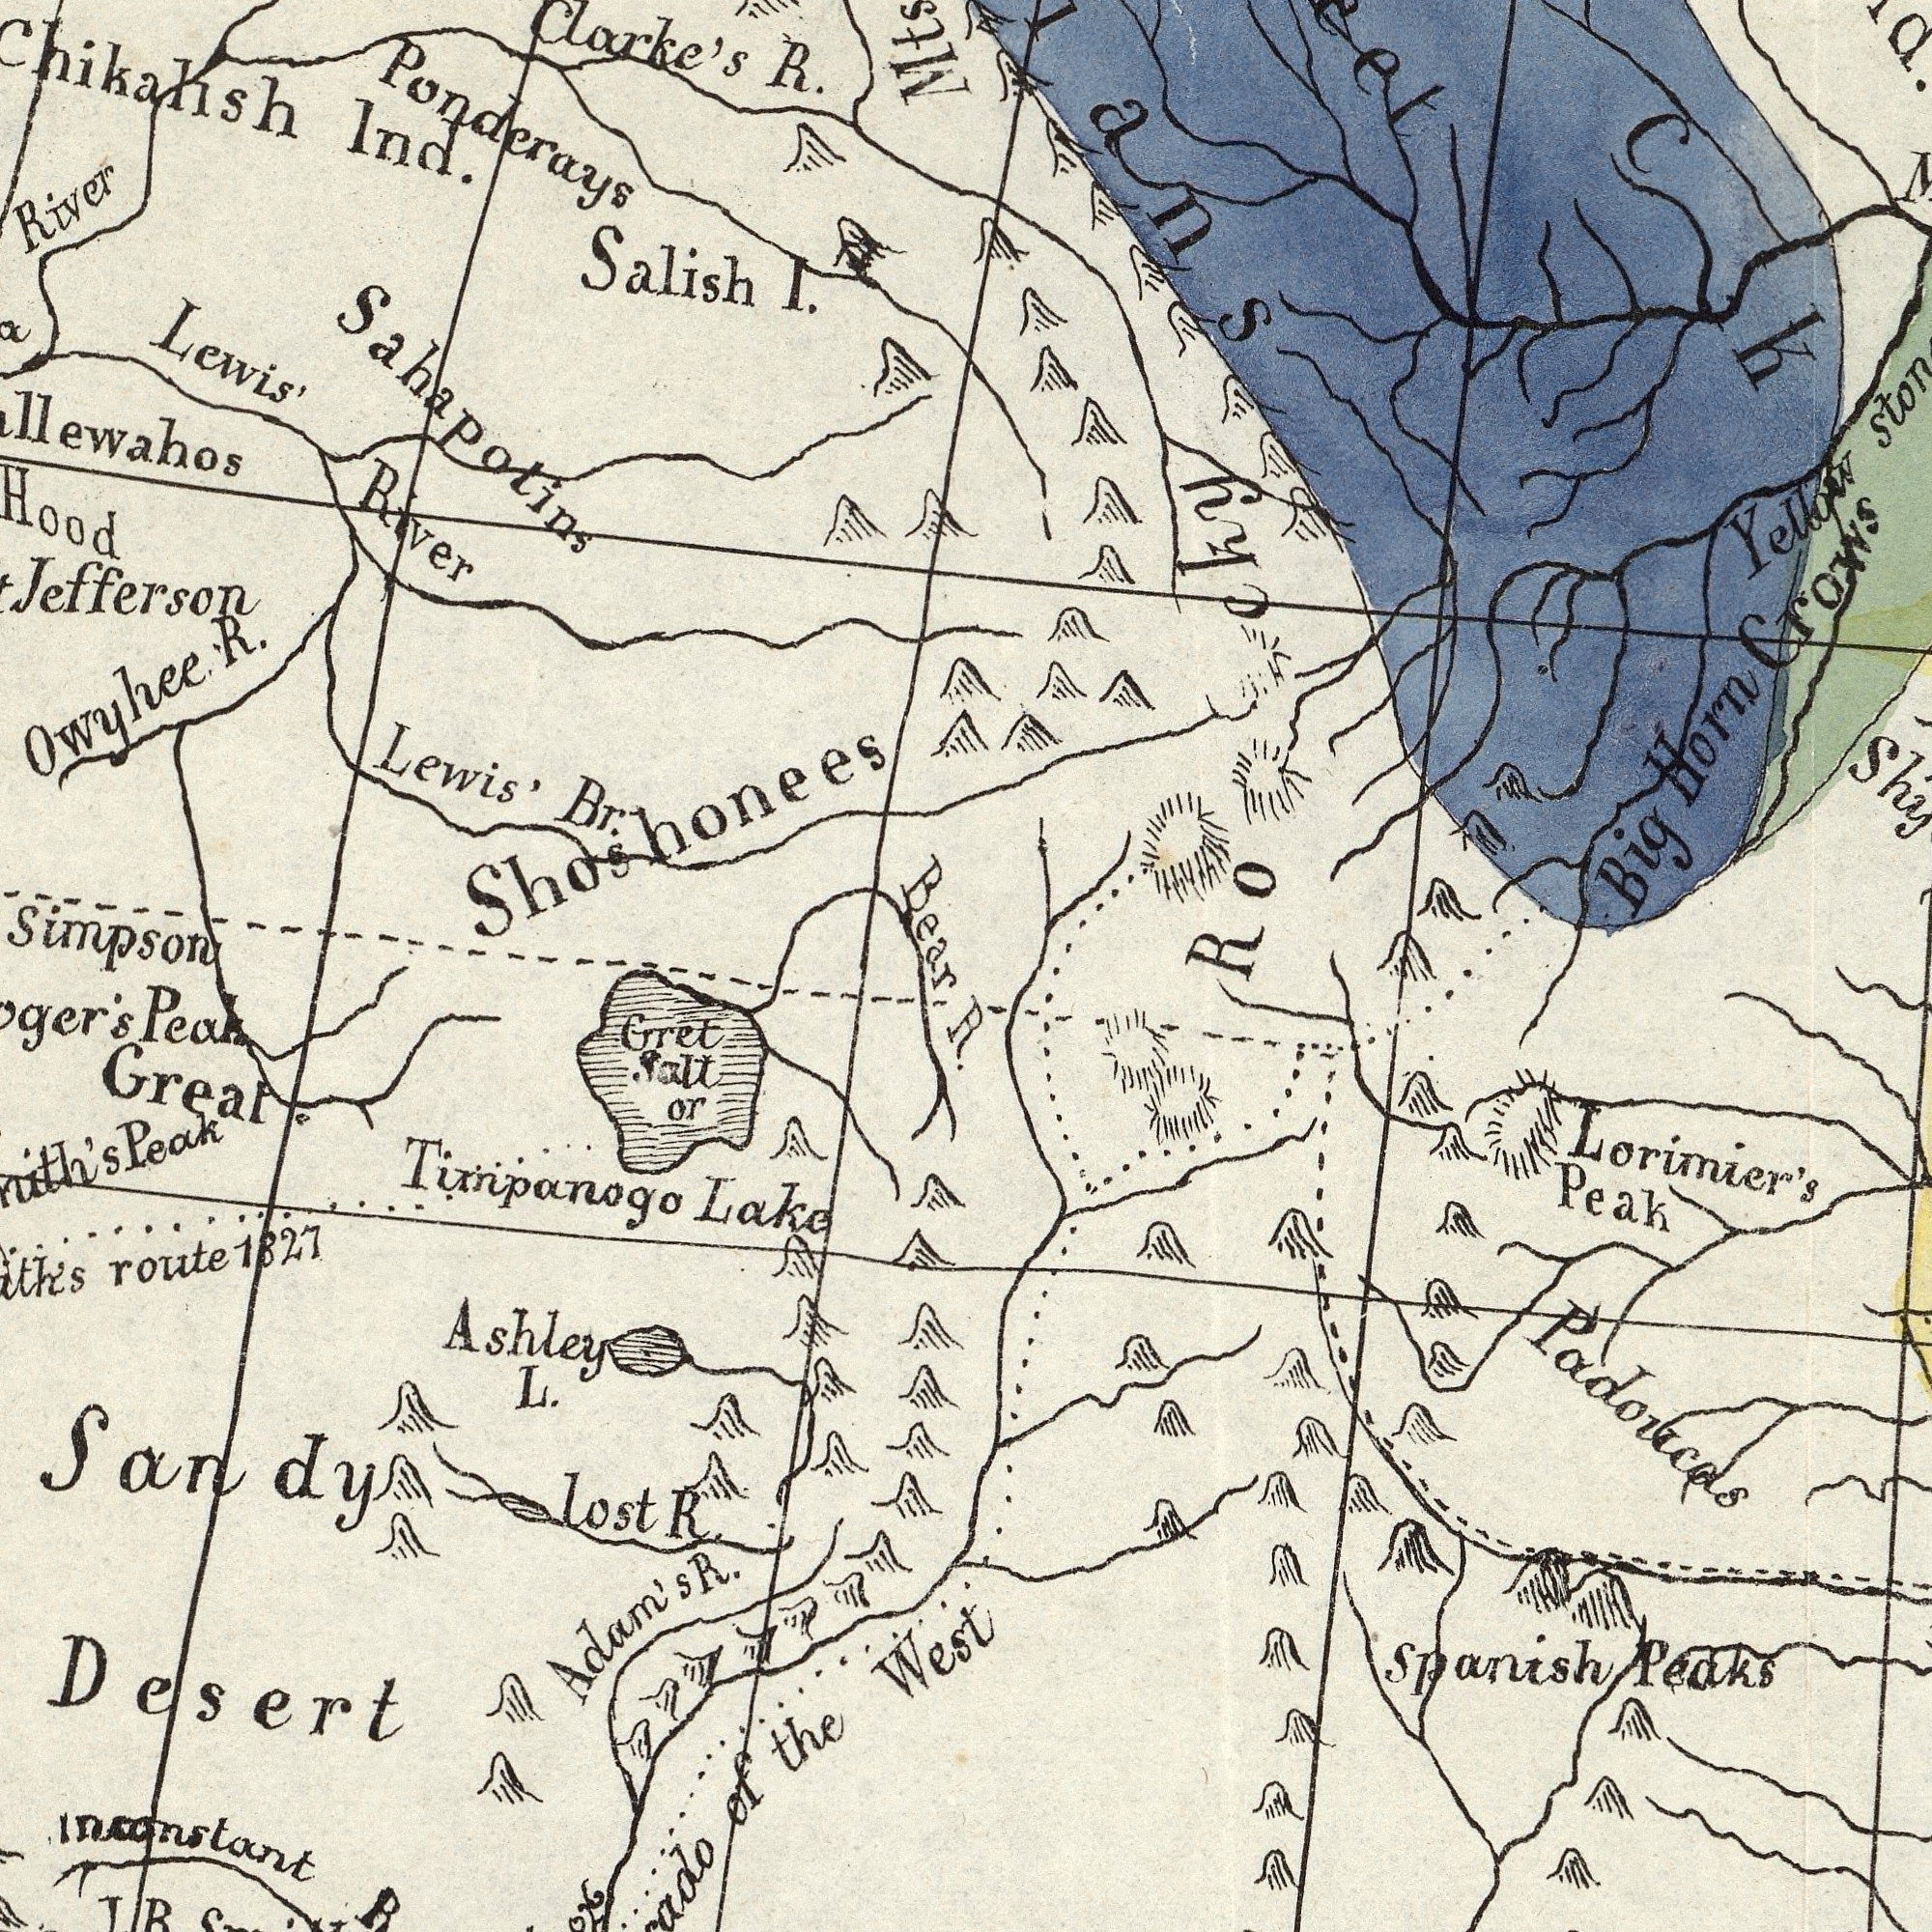What text is visible in the upper-left corner? Clarke's R. Lewis' Br. Salish I. Jefferson Owyhee R. Lewis' River River Chikalish Ind. Ponderays Sahapotins Hood Simpson Bear Shoshonees What text can you see in the bottom-left section? Tixnpanogo Lake Great Sandy Desert Gret salt or Ashley L. route 1827 Peak of the West Peak Inconstant RXXX lost R. JRS Adam's S. R. What text is shown in the top-right quadrant? Ro cky Yellow Big Horn Crows Sha ###ch What text is visible in the lower-right corner? Lorimier's Peak Spanish Peaks Padoucos 